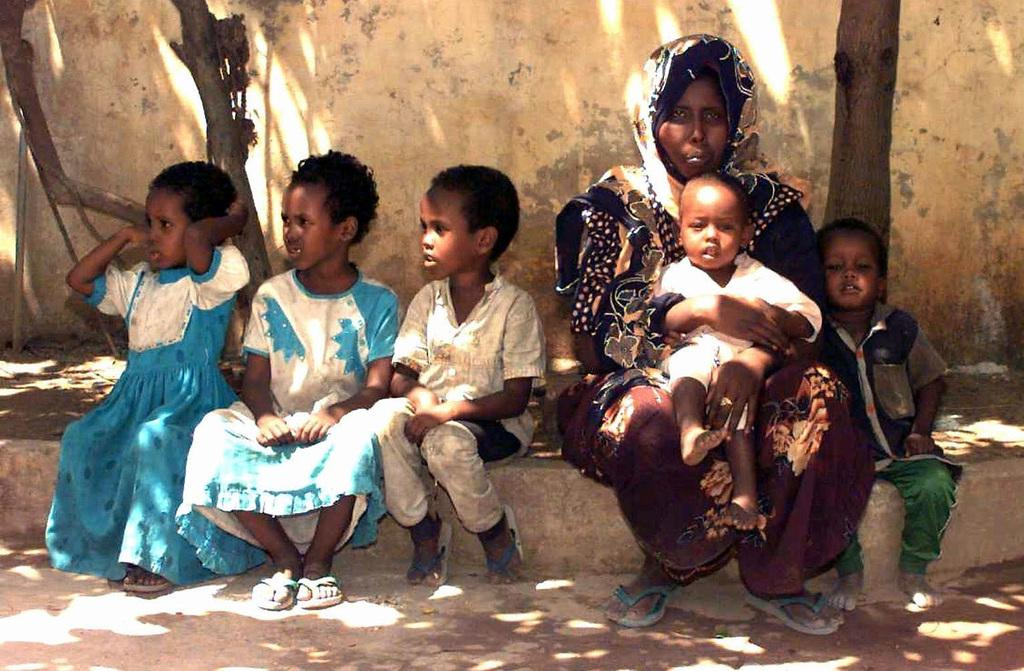What are the persons in the image doing? The persons in the image are sitting. On what surface are the persons sitting? The persons are sitting on a surface. What can be seen in the background of the image? There is a wall and trees visible in the background of the image. What type of lamp is hanging from the trees in the image? There is no lamp present in the image; only a wall and trees are visible in the background. 